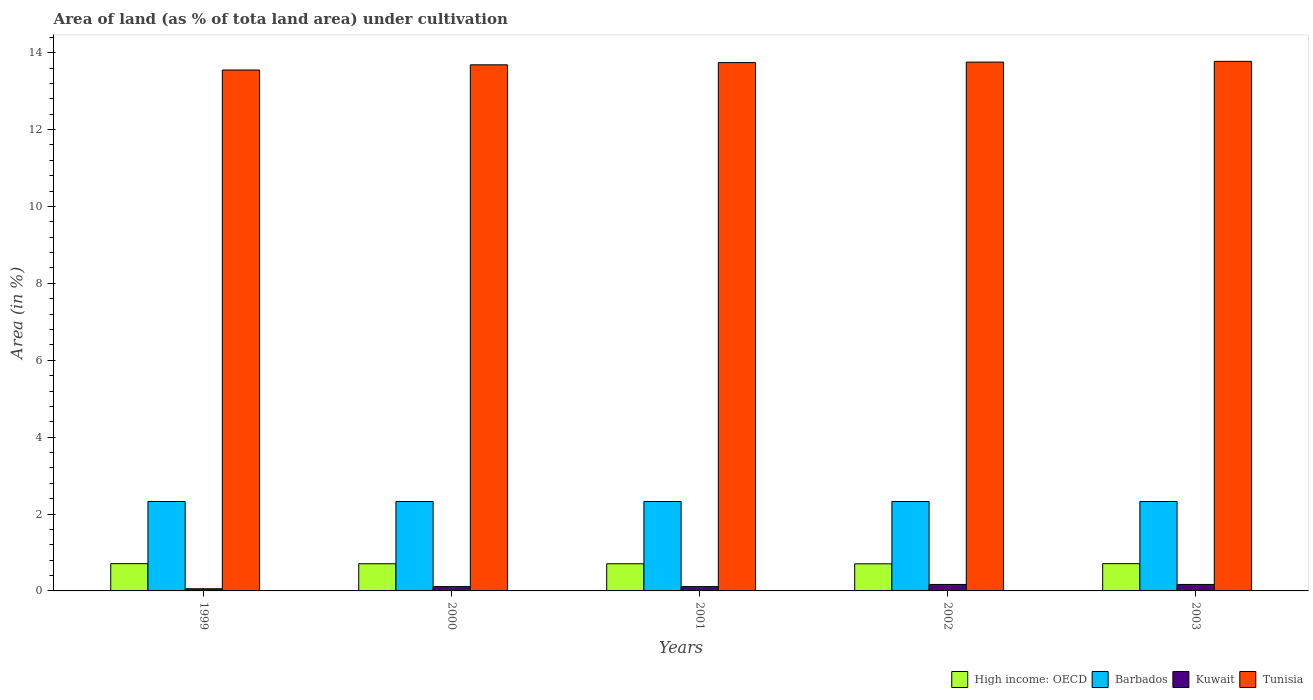Are the number of bars per tick equal to the number of legend labels?
Give a very brief answer. Yes. How many bars are there on the 5th tick from the left?
Offer a terse response. 4. What is the label of the 4th group of bars from the left?
Offer a terse response. 2002. In how many cases, is the number of bars for a given year not equal to the number of legend labels?
Ensure brevity in your answer.  0. What is the percentage of land under cultivation in Kuwait in 2003?
Make the answer very short. 0.17. Across all years, what is the maximum percentage of land under cultivation in Kuwait?
Offer a terse response. 0.17. Across all years, what is the minimum percentage of land under cultivation in Tunisia?
Ensure brevity in your answer.  13.55. In which year was the percentage of land under cultivation in Barbados maximum?
Make the answer very short. 1999. In which year was the percentage of land under cultivation in Kuwait minimum?
Offer a terse response. 1999. What is the total percentage of land under cultivation in Kuwait in the graph?
Provide a succinct answer. 0.62. What is the difference between the percentage of land under cultivation in Tunisia in 1999 and that in 2002?
Your response must be concise. -0.21. What is the difference between the percentage of land under cultivation in Kuwait in 2000 and the percentage of land under cultivation in Barbados in 2001?
Ensure brevity in your answer.  -2.21. What is the average percentage of land under cultivation in Barbados per year?
Your response must be concise. 2.33. In the year 1999, what is the difference between the percentage of land under cultivation in Kuwait and percentage of land under cultivation in High income: OECD?
Make the answer very short. -0.65. Is the difference between the percentage of land under cultivation in Kuwait in 2001 and 2002 greater than the difference between the percentage of land under cultivation in High income: OECD in 2001 and 2002?
Your response must be concise. No. What is the difference between the highest and the lowest percentage of land under cultivation in Barbados?
Offer a terse response. 0. In how many years, is the percentage of land under cultivation in High income: OECD greater than the average percentage of land under cultivation in High income: OECD taken over all years?
Offer a very short reply. 2. What does the 3rd bar from the left in 2002 represents?
Your answer should be very brief. Kuwait. What does the 3rd bar from the right in 1999 represents?
Your answer should be compact. Barbados. How many bars are there?
Your answer should be very brief. 20. Are all the bars in the graph horizontal?
Give a very brief answer. No. Does the graph contain any zero values?
Offer a terse response. No. Does the graph contain grids?
Provide a succinct answer. No. What is the title of the graph?
Offer a very short reply. Area of land (as % of tota land area) under cultivation. Does "New Zealand" appear as one of the legend labels in the graph?
Provide a succinct answer. No. What is the label or title of the X-axis?
Ensure brevity in your answer.  Years. What is the label or title of the Y-axis?
Keep it short and to the point. Area (in %). What is the Area (in %) in High income: OECD in 1999?
Provide a short and direct response. 0.71. What is the Area (in %) in Barbados in 1999?
Provide a succinct answer. 2.33. What is the Area (in %) in Kuwait in 1999?
Provide a short and direct response. 0.06. What is the Area (in %) of Tunisia in 1999?
Give a very brief answer. 13.55. What is the Area (in %) in High income: OECD in 2000?
Your answer should be very brief. 0.71. What is the Area (in %) of Barbados in 2000?
Provide a succinct answer. 2.33. What is the Area (in %) in Kuwait in 2000?
Provide a short and direct response. 0.11. What is the Area (in %) of Tunisia in 2000?
Your answer should be compact. 13.68. What is the Area (in %) in High income: OECD in 2001?
Offer a terse response. 0.71. What is the Area (in %) in Barbados in 2001?
Your response must be concise. 2.33. What is the Area (in %) of Kuwait in 2001?
Make the answer very short. 0.11. What is the Area (in %) in Tunisia in 2001?
Your response must be concise. 13.74. What is the Area (in %) of High income: OECD in 2002?
Give a very brief answer. 0.7. What is the Area (in %) of Barbados in 2002?
Your response must be concise. 2.33. What is the Area (in %) in Kuwait in 2002?
Offer a terse response. 0.17. What is the Area (in %) of Tunisia in 2002?
Offer a terse response. 13.76. What is the Area (in %) of High income: OECD in 2003?
Provide a succinct answer. 0.71. What is the Area (in %) of Barbados in 2003?
Offer a very short reply. 2.33. What is the Area (in %) of Kuwait in 2003?
Offer a very short reply. 0.17. What is the Area (in %) of Tunisia in 2003?
Provide a succinct answer. 13.77. Across all years, what is the maximum Area (in %) of High income: OECD?
Ensure brevity in your answer.  0.71. Across all years, what is the maximum Area (in %) of Barbados?
Give a very brief answer. 2.33. Across all years, what is the maximum Area (in %) of Kuwait?
Make the answer very short. 0.17. Across all years, what is the maximum Area (in %) of Tunisia?
Offer a terse response. 13.77. Across all years, what is the minimum Area (in %) in High income: OECD?
Your answer should be compact. 0.7. Across all years, what is the minimum Area (in %) in Barbados?
Offer a terse response. 2.33. Across all years, what is the minimum Area (in %) in Kuwait?
Provide a succinct answer. 0.06. Across all years, what is the minimum Area (in %) in Tunisia?
Give a very brief answer. 13.55. What is the total Area (in %) in High income: OECD in the graph?
Keep it short and to the point. 3.54. What is the total Area (in %) of Barbados in the graph?
Provide a short and direct response. 11.63. What is the total Area (in %) of Kuwait in the graph?
Give a very brief answer. 0.62. What is the total Area (in %) of Tunisia in the graph?
Ensure brevity in your answer.  68.51. What is the difference between the Area (in %) in High income: OECD in 1999 and that in 2000?
Your answer should be very brief. 0. What is the difference between the Area (in %) in Barbados in 1999 and that in 2000?
Provide a succinct answer. 0. What is the difference between the Area (in %) in Kuwait in 1999 and that in 2000?
Ensure brevity in your answer.  -0.06. What is the difference between the Area (in %) in Tunisia in 1999 and that in 2000?
Offer a very short reply. -0.14. What is the difference between the Area (in %) in High income: OECD in 1999 and that in 2001?
Provide a short and direct response. 0. What is the difference between the Area (in %) of Kuwait in 1999 and that in 2001?
Provide a succinct answer. -0.06. What is the difference between the Area (in %) in Tunisia in 1999 and that in 2001?
Give a very brief answer. -0.19. What is the difference between the Area (in %) of High income: OECD in 1999 and that in 2002?
Your answer should be very brief. 0. What is the difference between the Area (in %) of Barbados in 1999 and that in 2002?
Ensure brevity in your answer.  0. What is the difference between the Area (in %) of Kuwait in 1999 and that in 2002?
Make the answer very short. -0.11. What is the difference between the Area (in %) in Tunisia in 1999 and that in 2002?
Make the answer very short. -0.21. What is the difference between the Area (in %) in Kuwait in 1999 and that in 2003?
Your answer should be very brief. -0.11. What is the difference between the Area (in %) in Tunisia in 1999 and that in 2003?
Provide a succinct answer. -0.23. What is the difference between the Area (in %) in Barbados in 2000 and that in 2001?
Your answer should be compact. 0. What is the difference between the Area (in %) in Kuwait in 2000 and that in 2001?
Your response must be concise. 0. What is the difference between the Area (in %) of Tunisia in 2000 and that in 2001?
Your answer should be very brief. -0.06. What is the difference between the Area (in %) of High income: OECD in 2000 and that in 2002?
Offer a very short reply. 0. What is the difference between the Area (in %) in Barbados in 2000 and that in 2002?
Offer a very short reply. 0. What is the difference between the Area (in %) of Kuwait in 2000 and that in 2002?
Ensure brevity in your answer.  -0.06. What is the difference between the Area (in %) of Tunisia in 2000 and that in 2002?
Provide a short and direct response. -0.07. What is the difference between the Area (in %) in High income: OECD in 2000 and that in 2003?
Your response must be concise. -0. What is the difference between the Area (in %) in Barbados in 2000 and that in 2003?
Provide a short and direct response. 0. What is the difference between the Area (in %) of Kuwait in 2000 and that in 2003?
Your answer should be very brief. -0.06. What is the difference between the Area (in %) of Tunisia in 2000 and that in 2003?
Your response must be concise. -0.09. What is the difference between the Area (in %) in High income: OECD in 2001 and that in 2002?
Provide a succinct answer. 0. What is the difference between the Area (in %) of Kuwait in 2001 and that in 2002?
Your answer should be compact. -0.06. What is the difference between the Area (in %) in Tunisia in 2001 and that in 2002?
Make the answer very short. -0.01. What is the difference between the Area (in %) of High income: OECD in 2001 and that in 2003?
Give a very brief answer. -0. What is the difference between the Area (in %) in Barbados in 2001 and that in 2003?
Keep it short and to the point. 0. What is the difference between the Area (in %) in Kuwait in 2001 and that in 2003?
Offer a terse response. -0.06. What is the difference between the Area (in %) in Tunisia in 2001 and that in 2003?
Provide a succinct answer. -0.03. What is the difference between the Area (in %) in High income: OECD in 2002 and that in 2003?
Provide a short and direct response. -0. What is the difference between the Area (in %) of Barbados in 2002 and that in 2003?
Ensure brevity in your answer.  0. What is the difference between the Area (in %) of Kuwait in 2002 and that in 2003?
Your answer should be compact. 0. What is the difference between the Area (in %) of Tunisia in 2002 and that in 2003?
Provide a succinct answer. -0.02. What is the difference between the Area (in %) in High income: OECD in 1999 and the Area (in %) in Barbados in 2000?
Your answer should be very brief. -1.62. What is the difference between the Area (in %) in High income: OECD in 1999 and the Area (in %) in Kuwait in 2000?
Make the answer very short. 0.6. What is the difference between the Area (in %) of High income: OECD in 1999 and the Area (in %) of Tunisia in 2000?
Provide a succinct answer. -12.98. What is the difference between the Area (in %) in Barbados in 1999 and the Area (in %) in Kuwait in 2000?
Provide a short and direct response. 2.21. What is the difference between the Area (in %) in Barbados in 1999 and the Area (in %) in Tunisia in 2000?
Offer a very short reply. -11.36. What is the difference between the Area (in %) of Kuwait in 1999 and the Area (in %) of Tunisia in 2000?
Offer a terse response. -13.63. What is the difference between the Area (in %) in High income: OECD in 1999 and the Area (in %) in Barbados in 2001?
Make the answer very short. -1.62. What is the difference between the Area (in %) in High income: OECD in 1999 and the Area (in %) in Kuwait in 2001?
Give a very brief answer. 0.6. What is the difference between the Area (in %) in High income: OECD in 1999 and the Area (in %) in Tunisia in 2001?
Your response must be concise. -13.03. What is the difference between the Area (in %) of Barbados in 1999 and the Area (in %) of Kuwait in 2001?
Provide a short and direct response. 2.21. What is the difference between the Area (in %) of Barbados in 1999 and the Area (in %) of Tunisia in 2001?
Offer a terse response. -11.42. What is the difference between the Area (in %) in Kuwait in 1999 and the Area (in %) in Tunisia in 2001?
Ensure brevity in your answer.  -13.69. What is the difference between the Area (in %) of High income: OECD in 1999 and the Area (in %) of Barbados in 2002?
Give a very brief answer. -1.62. What is the difference between the Area (in %) of High income: OECD in 1999 and the Area (in %) of Kuwait in 2002?
Provide a succinct answer. 0.54. What is the difference between the Area (in %) of High income: OECD in 1999 and the Area (in %) of Tunisia in 2002?
Give a very brief answer. -13.05. What is the difference between the Area (in %) in Barbados in 1999 and the Area (in %) in Kuwait in 2002?
Give a very brief answer. 2.16. What is the difference between the Area (in %) of Barbados in 1999 and the Area (in %) of Tunisia in 2002?
Your answer should be very brief. -11.43. What is the difference between the Area (in %) in Kuwait in 1999 and the Area (in %) in Tunisia in 2002?
Ensure brevity in your answer.  -13.7. What is the difference between the Area (in %) in High income: OECD in 1999 and the Area (in %) in Barbados in 2003?
Provide a succinct answer. -1.62. What is the difference between the Area (in %) of High income: OECD in 1999 and the Area (in %) of Kuwait in 2003?
Make the answer very short. 0.54. What is the difference between the Area (in %) in High income: OECD in 1999 and the Area (in %) in Tunisia in 2003?
Provide a short and direct response. -13.07. What is the difference between the Area (in %) of Barbados in 1999 and the Area (in %) of Kuwait in 2003?
Your answer should be compact. 2.16. What is the difference between the Area (in %) of Barbados in 1999 and the Area (in %) of Tunisia in 2003?
Ensure brevity in your answer.  -11.45. What is the difference between the Area (in %) of Kuwait in 1999 and the Area (in %) of Tunisia in 2003?
Your answer should be very brief. -13.72. What is the difference between the Area (in %) of High income: OECD in 2000 and the Area (in %) of Barbados in 2001?
Offer a terse response. -1.62. What is the difference between the Area (in %) of High income: OECD in 2000 and the Area (in %) of Kuwait in 2001?
Your response must be concise. 0.59. What is the difference between the Area (in %) of High income: OECD in 2000 and the Area (in %) of Tunisia in 2001?
Ensure brevity in your answer.  -13.04. What is the difference between the Area (in %) of Barbados in 2000 and the Area (in %) of Kuwait in 2001?
Give a very brief answer. 2.21. What is the difference between the Area (in %) in Barbados in 2000 and the Area (in %) in Tunisia in 2001?
Provide a succinct answer. -11.42. What is the difference between the Area (in %) of Kuwait in 2000 and the Area (in %) of Tunisia in 2001?
Make the answer very short. -13.63. What is the difference between the Area (in %) of High income: OECD in 2000 and the Area (in %) of Barbados in 2002?
Give a very brief answer. -1.62. What is the difference between the Area (in %) of High income: OECD in 2000 and the Area (in %) of Kuwait in 2002?
Ensure brevity in your answer.  0.54. What is the difference between the Area (in %) in High income: OECD in 2000 and the Area (in %) in Tunisia in 2002?
Keep it short and to the point. -13.05. What is the difference between the Area (in %) of Barbados in 2000 and the Area (in %) of Kuwait in 2002?
Ensure brevity in your answer.  2.16. What is the difference between the Area (in %) in Barbados in 2000 and the Area (in %) in Tunisia in 2002?
Make the answer very short. -11.43. What is the difference between the Area (in %) in Kuwait in 2000 and the Area (in %) in Tunisia in 2002?
Provide a short and direct response. -13.64. What is the difference between the Area (in %) in High income: OECD in 2000 and the Area (in %) in Barbados in 2003?
Make the answer very short. -1.62. What is the difference between the Area (in %) of High income: OECD in 2000 and the Area (in %) of Kuwait in 2003?
Ensure brevity in your answer.  0.54. What is the difference between the Area (in %) in High income: OECD in 2000 and the Area (in %) in Tunisia in 2003?
Your answer should be very brief. -13.07. What is the difference between the Area (in %) of Barbados in 2000 and the Area (in %) of Kuwait in 2003?
Provide a succinct answer. 2.16. What is the difference between the Area (in %) in Barbados in 2000 and the Area (in %) in Tunisia in 2003?
Your answer should be compact. -11.45. What is the difference between the Area (in %) of Kuwait in 2000 and the Area (in %) of Tunisia in 2003?
Your answer should be compact. -13.66. What is the difference between the Area (in %) of High income: OECD in 2001 and the Area (in %) of Barbados in 2002?
Provide a succinct answer. -1.62. What is the difference between the Area (in %) in High income: OECD in 2001 and the Area (in %) in Kuwait in 2002?
Offer a terse response. 0.54. What is the difference between the Area (in %) of High income: OECD in 2001 and the Area (in %) of Tunisia in 2002?
Offer a very short reply. -13.05. What is the difference between the Area (in %) of Barbados in 2001 and the Area (in %) of Kuwait in 2002?
Provide a short and direct response. 2.16. What is the difference between the Area (in %) of Barbados in 2001 and the Area (in %) of Tunisia in 2002?
Your answer should be very brief. -11.43. What is the difference between the Area (in %) in Kuwait in 2001 and the Area (in %) in Tunisia in 2002?
Offer a very short reply. -13.64. What is the difference between the Area (in %) of High income: OECD in 2001 and the Area (in %) of Barbados in 2003?
Your response must be concise. -1.62. What is the difference between the Area (in %) in High income: OECD in 2001 and the Area (in %) in Kuwait in 2003?
Ensure brevity in your answer.  0.54. What is the difference between the Area (in %) in High income: OECD in 2001 and the Area (in %) in Tunisia in 2003?
Keep it short and to the point. -13.07. What is the difference between the Area (in %) in Barbados in 2001 and the Area (in %) in Kuwait in 2003?
Offer a terse response. 2.16. What is the difference between the Area (in %) of Barbados in 2001 and the Area (in %) of Tunisia in 2003?
Offer a very short reply. -11.45. What is the difference between the Area (in %) in Kuwait in 2001 and the Area (in %) in Tunisia in 2003?
Give a very brief answer. -13.66. What is the difference between the Area (in %) in High income: OECD in 2002 and the Area (in %) in Barbados in 2003?
Ensure brevity in your answer.  -1.62. What is the difference between the Area (in %) in High income: OECD in 2002 and the Area (in %) in Kuwait in 2003?
Ensure brevity in your answer.  0.54. What is the difference between the Area (in %) in High income: OECD in 2002 and the Area (in %) in Tunisia in 2003?
Your answer should be very brief. -13.07. What is the difference between the Area (in %) in Barbados in 2002 and the Area (in %) in Kuwait in 2003?
Give a very brief answer. 2.16. What is the difference between the Area (in %) of Barbados in 2002 and the Area (in %) of Tunisia in 2003?
Provide a short and direct response. -11.45. What is the difference between the Area (in %) of Kuwait in 2002 and the Area (in %) of Tunisia in 2003?
Offer a terse response. -13.61. What is the average Area (in %) of High income: OECD per year?
Your answer should be compact. 0.71. What is the average Area (in %) in Barbados per year?
Your answer should be very brief. 2.33. What is the average Area (in %) of Kuwait per year?
Make the answer very short. 0.12. What is the average Area (in %) of Tunisia per year?
Provide a succinct answer. 13.7. In the year 1999, what is the difference between the Area (in %) in High income: OECD and Area (in %) in Barbados?
Your answer should be compact. -1.62. In the year 1999, what is the difference between the Area (in %) in High income: OECD and Area (in %) in Kuwait?
Keep it short and to the point. 0.65. In the year 1999, what is the difference between the Area (in %) in High income: OECD and Area (in %) in Tunisia?
Ensure brevity in your answer.  -12.84. In the year 1999, what is the difference between the Area (in %) in Barbados and Area (in %) in Kuwait?
Give a very brief answer. 2.27. In the year 1999, what is the difference between the Area (in %) in Barbados and Area (in %) in Tunisia?
Your response must be concise. -11.22. In the year 1999, what is the difference between the Area (in %) of Kuwait and Area (in %) of Tunisia?
Ensure brevity in your answer.  -13.49. In the year 2000, what is the difference between the Area (in %) of High income: OECD and Area (in %) of Barbados?
Make the answer very short. -1.62. In the year 2000, what is the difference between the Area (in %) of High income: OECD and Area (in %) of Kuwait?
Provide a short and direct response. 0.59. In the year 2000, what is the difference between the Area (in %) in High income: OECD and Area (in %) in Tunisia?
Ensure brevity in your answer.  -12.98. In the year 2000, what is the difference between the Area (in %) of Barbados and Area (in %) of Kuwait?
Your response must be concise. 2.21. In the year 2000, what is the difference between the Area (in %) in Barbados and Area (in %) in Tunisia?
Offer a terse response. -11.36. In the year 2000, what is the difference between the Area (in %) in Kuwait and Area (in %) in Tunisia?
Ensure brevity in your answer.  -13.57. In the year 2001, what is the difference between the Area (in %) in High income: OECD and Area (in %) in Barbados?
Your answer should be compact. -1.62. In the year 2001, what is the difference between the Area (in %) in High income: OECD and Area (in %) in Kuwait?
Your response must be concise. 0.59. In the year 2001, what is the difference between the Area (in %) in High income: OECD and Area (in %) in Tunisia?
Offer a terse response. -13.04. In the year 2001, what is the difference between the Area (in %) in Barbados and Area (in %) in Kuwait?
Offer a very short reply. 2.21. In the year 2001, what is the difference between the Area (in %) of Barbados and Area (in %) of Tunisia?
Provide a succinct answer. -11.42. In the year 2001, what is the difference between the Area (in %) of Kuwait and Area (in %) of Tunisia?
Make the answer very short. -13.63. In the year 2002, what is the difference between the Area (in %) of High income: OECD and Area (in %) of Barbados?
Offer a terse response. -1.62. In the year 2002, what is the difference between the Area (in %) of High income: OECD and Area (in %) of Kuwait?
Provide a succinct answer. 0.54. In the year 2002, what is the difference between the Area (in %) in High income: OECD and Area (in %) in Tunisia?
Ensure brevity in your answer.  -13.05. In the year 2002, what is the difference between the Area (in %) in Barbados and Area (in %) in Kuwait?
Provide a short and direct response. 2.16. In the year 2002, what is the difference between the Area (in %) in Barbados and Area (in %) in Tunisia?
Provide a succinct answer. -11.43. In the year 2002, what is the difference between the Area (in %) in Kuwait and Area (in %) in Tunisia?
Make the answer very short. -13.59. In the year 2003, what is the difference between the Area (in %) in High income: OECD and Area (in %) in Barbados?
Provide a short and direct response. -1.62. In the year 2003, what is the difference between the Area (in %) of High income: OECD and Area (in %) of Kuwait?
Your response must be concise. 0.54. In the year 2003, what is the difference between the Area (in %) in High income: OECD and Area (in %) in Tunisia?
Give a very brief answer. -13.07. In the year 2003, what is the difference between the Area (in %) in Barbados and Area (in %) in Kuwait?
Ensure brevity in your answer.  2.16. In the year 2003, what is the difference between the Area (in %) of Barbados and Area (in %) of Tunisia?
Ensure brevity in your answer.  -11.45. In the year 2003, what is the difference between the Area (in %) of Kuwait and Area (in %) of Tunisia?
Your response must be concise. -13.61. What is the ratio of the Area (in %) of High income: OECD in 1999 to that in 2000?
Keep it short and to the point. 1. What is the ratio of the Area (in %) of Barbados in 1999 to that in 2000?
Your answer should be very brief. 1. What is the ratio of the Area (in %) of Kuwait in 1999 to that in 2000?
Keep it short and to the point. 0.5. What is the ratio of the Area (in %) in Tunisia in 1999 to that in 2000?
Keep it short and to the point. 0.99. What is the ratio of the Area (in %) of High income: OECD in 1999 to that in 2001?
Offer a terse response. 1. What is the ratio of the Area (in %) in Tunisia in 1999 to that in 2001?
Your answer should be compact. 0.99. What is the ratio of the Area (in %) in Barbados in 1999 to that in 2002?
Give a very brief answer. 1. What is the ratio of the Area (in %) in Barbados in 1999 to that in 2003?
Give a very brief answer. 1. What is the ratio of the Area (in %) in Tunisia in 1999 to that in 2003?
Make the answer very short. 0.98. What is the ratio of the Area (in %) in Barbados in 2000 to that in 2001?
Your response must be concise. 1. What is the ratio of the Area (in %) in Tunisia in 2000 to that in 2001?
Your answer should be compact. 1. What is the ratio of the Area (in %) in Kuwait in 2000 to that in 2002?
Provide a succinct answer. 0.67. What is the ratio of the Area (in %) of Barbados in 2000 to that in 2003?
Keep it short and to the point. 1. What is the ratio of the Area (in %) in Tunisia in 2000 to that in 2003?
Your answer should be very brief. 0.99. What is the ratio of the Area (in %) in High income: OECD in 2001 to that in 2002?
Give a very brief answer. 1. What is the ratio of the Area (in %) in Tunisia in 2001 to that in 2002?
Make the answer very short. 1. What is the ratio of the Area (in %) in Barbados in 2001 to that in 2003?
Ensure brevity in your answer.  1. What is the ratio of the Area (in %) of Tunisia in 2001 to that in 2003?
Provide a short and direct response. 1. What is the ratio of the Area (in %) of High income: OECD in 2002 to that in 2003?
Give a very brief answer. 0.99. What is the ratio of the Area (in %) of Barbados in 2002 to that in 2003?
Your answer should be very brief. 1. What is the difference between the highest and the second highest Area (in %) of High income: OECD?
Provide a succinct answer. 0. What is the difference between the highest and the second highest Area (in %) of Kuwait?
Provide a short and direct response. 0. What is the difference between the highest and the second highest Area (in %) of Tunisia?
Provide a short and direct response. 0.02. What is the difference between the highest and the lowest Area (in %) in High income: OECD?
Make the answer very short. 0. What is the difference between the highest and the lowest Area (in %) in Barbados?
Your response must be concise. 0. What is the difference between the highest and the lowest Area (in %) in Kuwait?
Provide a short and direct response. 0.11. What is the difference between the highest and the lowest Area (in %) of Tunisia?
Your answer should be very brief. 0.23. 